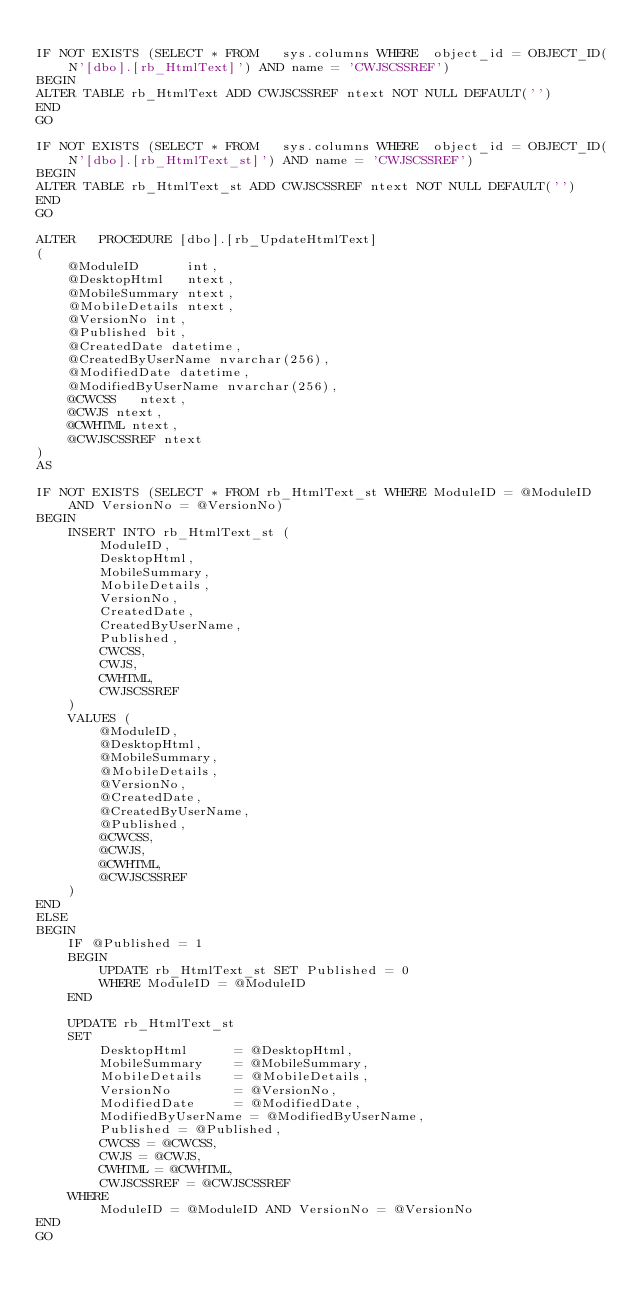<code> <loc_0><loc_0><loc_500><loc_500><_SQL_>
IF NOT EXISTS (SELECT * FROM   sys.columns WHERE  object_id = OBJECT_ID(N'[dbo].[rb_HtmlText]') AND name = 'CWJSCSSREF')
BEGIN
ALTER TABLE rb_HtmlText ADD CWJSCSSREF ntext NOT NULL DEFAULT('')
END
GO

IF NOT EXISTS (SELECT * FROM   sys.columns WHERE  object_id = OBJECT_ID(N'[dbo].[rb_HtmlText_st]') AND name = 'CWJSCSSREF')
BEGIN
ALTER TABLE rb_HtmlText_st ADD CWJSCSSREF ntext NOT NULL DEFAULT('')
END
GO

ALTER   PROCEDURE [dbo].[rb_UpdateHtmlText]
(
    @ModuleID      int,
    @DesktopHtml   ntext,
    @MobileSummary ntext,
    @MobileDetails ntext,
	@VersionNo int,
	@Published bit,
	@CreatedDate datetime,
	@CreatedByUserName nvarchar(256),
	@ModifiedDate datetime,
	@ModifiedByUserName nvarchar(256),
	@CWCSS   ntext,
    @CWJS ntext,
    @CWHTML ntext,
	@CWJSCSSREF ntext
)
AS

IF NOT EXISTS (SELECT * FROM rb_HtmlText_st WHERE ModuleID = @ModuleID AND VersionNo = @VersionNo)
BEGIN
	INSERT INTO rb_HtmlText_st (
		ModuleID,
		DesktopHtml,
		MobileSummary,
		MobileDetails,
		VersionNo,
		CreatedDate,
		CreatedByUserName,
		Published,
		CWCSS,
		CWJS,
		CWHTML,
		CWJSCSSREF
	) 
	VALUES (
		@ModuleID,
		@DesktopHtml,
		@MobileSummary,
		@MobileDetails,
		@VersionNo,
		@CreatedDate,
		@CreatedByUserName,
		@Published,
		@CWCSS,
		@CWJS,
		@CWHTML,
		@CWJSCSSREF
	)
END
ELSE
BEGIN
	IF @Published = 1 
	BEGIN
		UPDATE rb_HtmlText_st SET Published = 0
		WHERE ModuleID = @ModuleID
	END

	UPDATE rb_HtmlText_st
	SET
		DesktopHtml		 = @DesktopHtml,
		MobileSummary	 = @MobileSummary,
		MobileDetails	 = @MobileDetails,
		VersionNo		 = @VersionNo,
		ModifiedDate	 = @ModifiedDate,
		ModifiedByUserName = @ModifiedByUserName,
		Published = @Published,
		CWCSS = @CWCSS,
		CWJS = @CWJS,
		CWHTML = @CWHTML,
		CWJSCSSREF = @CWJSCSSREF
	WHERE
		ModuleID = @ModuleID AND VersionNo = @VersionNo
END
GO
</code> 